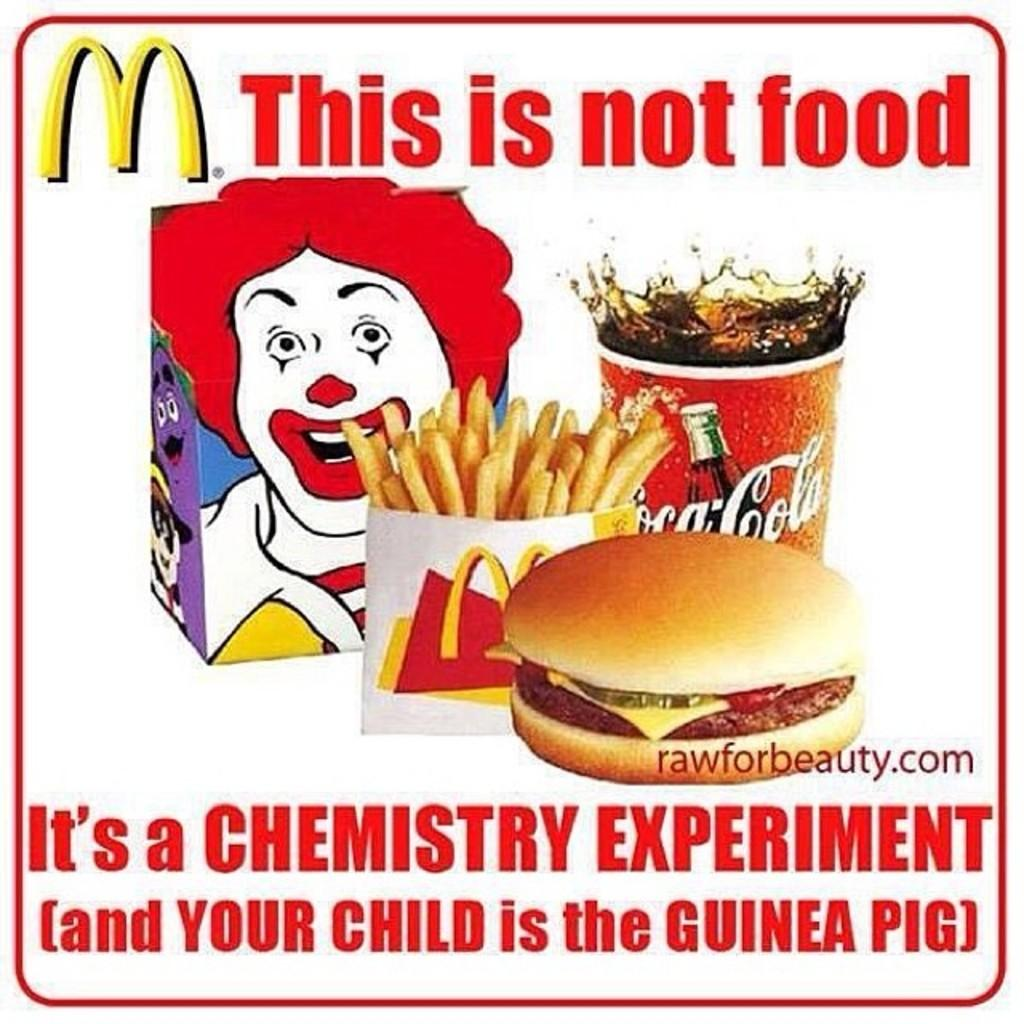What is featured on the poster in the image? There is a poster in the image, and it has writing on it. What type of food can be seen in the image? There is a burger, a glass with a drink, and french fries in a packet in the image. What is the animated image in the image? The facts do not specify the content of the animated image, so we cannot describe it. What color is the sky in the image? There is no sky visible in the image; it is an indoor scene. What reward is given to the person who completes the task in the image? There is no task or reward mentioned in the image. 